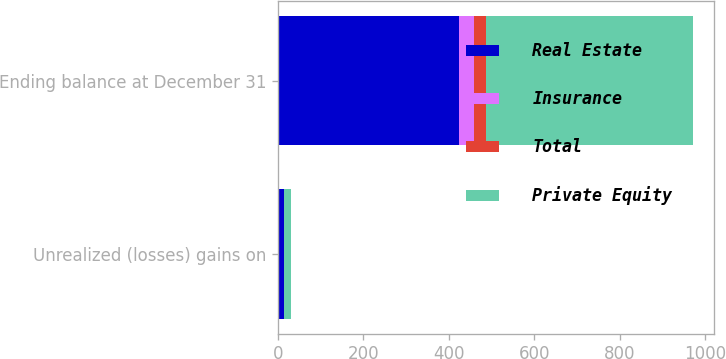<chart> <loc_0><loc_0><loc_500><loc_500><stacked_bar_chart><ecel><fcel>Unrealized (losses) gains on<fcel>Ending balance at December 31<nl><fcel>Real Estate<fcel>13<fcel>424<nl><fcel>Insurance<fcel>1<fcel>34<nl><fcel>Total<fcel>1<fcel>28<nl><fcel>Private Equity<fcel>15<fcel>486<nl></chart> 